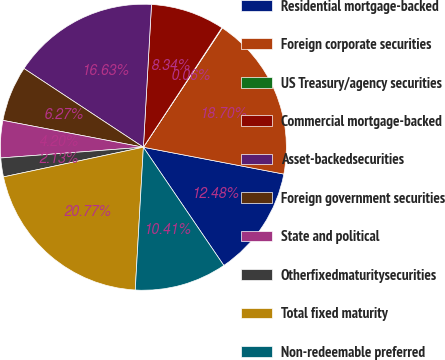<chart> <loc_0><loc_0><loc_500><loc_500><pie_chart><fcel>Residential mortgage-backed<fcel>Foreign corporate securities<fcel>US Treasury/agency securities<fcel>Commercial mortgage-backed<fcel>Asset-backedsecurities<fcel>Foreign government securities<fcel>State and political<fcel>Otherfixedmaturitysecurities<fcel>Total fixed maturity<fcel>Non-redeemable preferred<nl><fcel>12.48%<fcel>18.69%<fcel>0.06%<fcel>8.34%<fcel>16.62%<fcel>6.27%<fcel>4.2%<fcel>2.13%<fcel>20.76%<fcel>10.41%<nl></chart> 